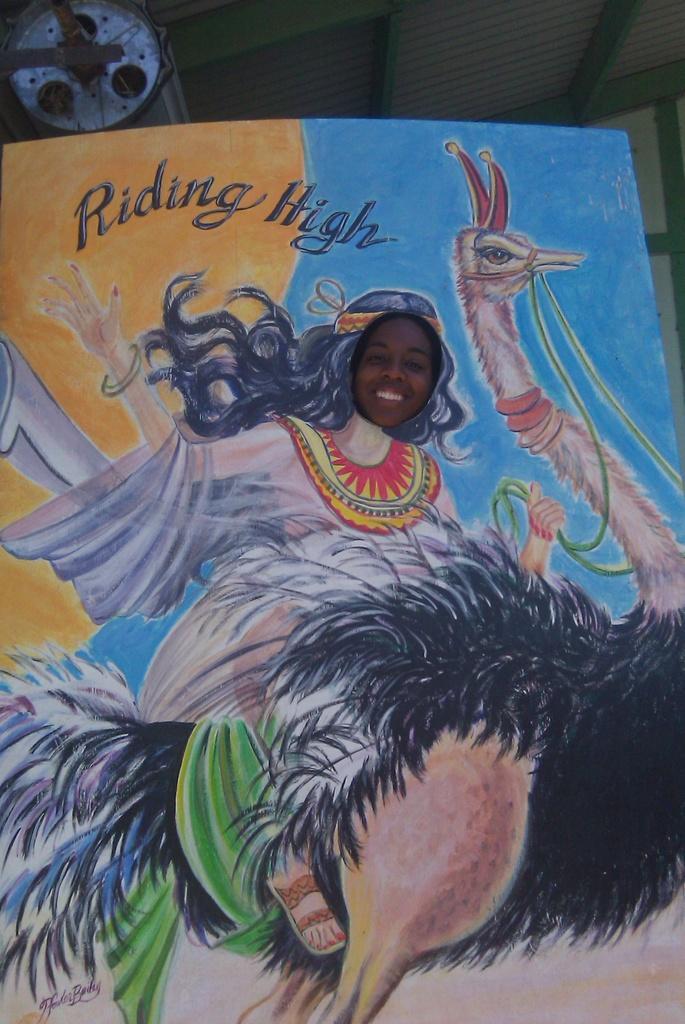How would you summarize this image in a sentence or two? In this picture there is poster of the girl riding the black color ostrich bird. Above there is a small quote written on the poster. 